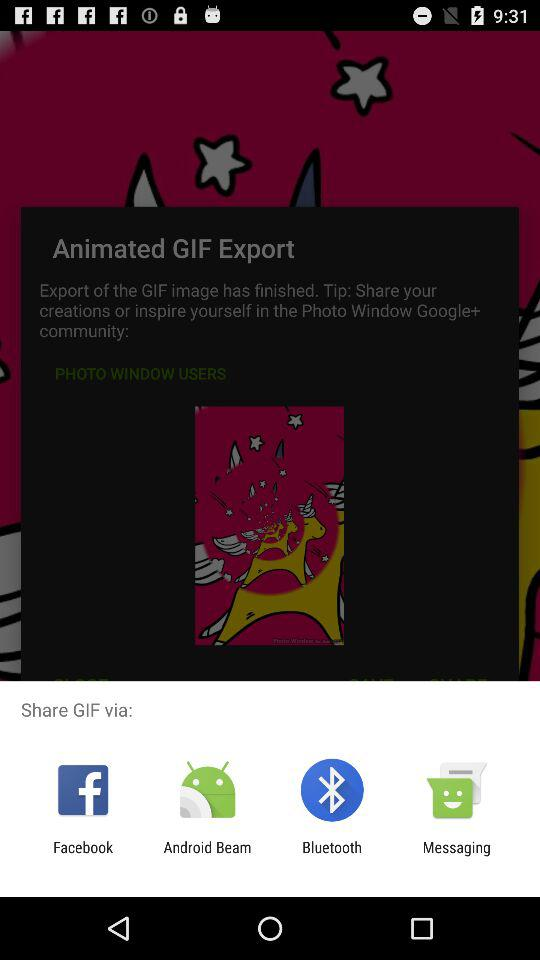Through which application can we share GIF? You can share through "Facebook", "Android Beam", "Bluetooth" and "Messaging". 